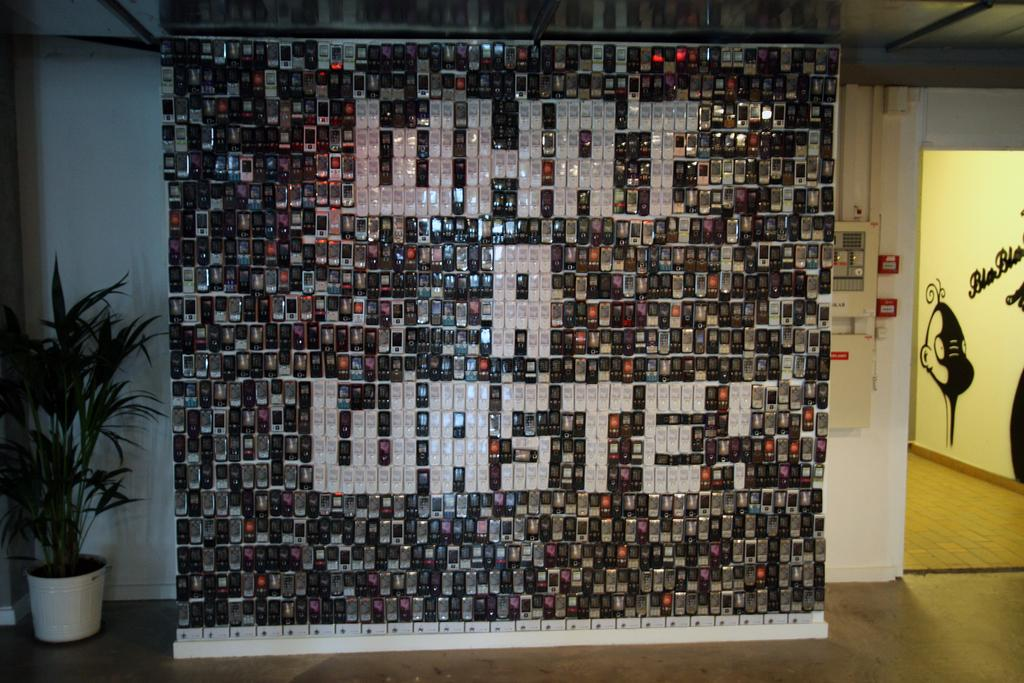<image>
Share a concise interpretation of the image provided. Wall in a buliding that says "What A Waste!" in white. 